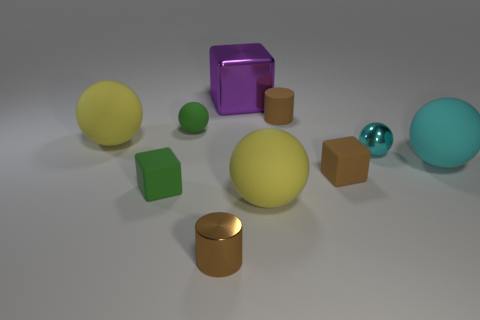Subtract all rubber blocks. How many blocks are left? 1 Subtract all purple cubes. How many cubes are left? 2 Subtract all cylinders. How many objects are left? 8 Subtract 1 cylinders. How many cylinders are left? 1 Subtract all green cylinders. How many cyan balls are left? 2 Subtract 0 purple spheres. How many objects are left? 10 Subtract all red cubes. Subtract all blue balls. How many cubes are left? 3 Subtract all cyan balls. Subtract all green matte blocks. How many objects are left? 7 Add 9 small cyan objects. How many small cyan objects are left? 10 Add 1 small things. How many small things exist? 7 